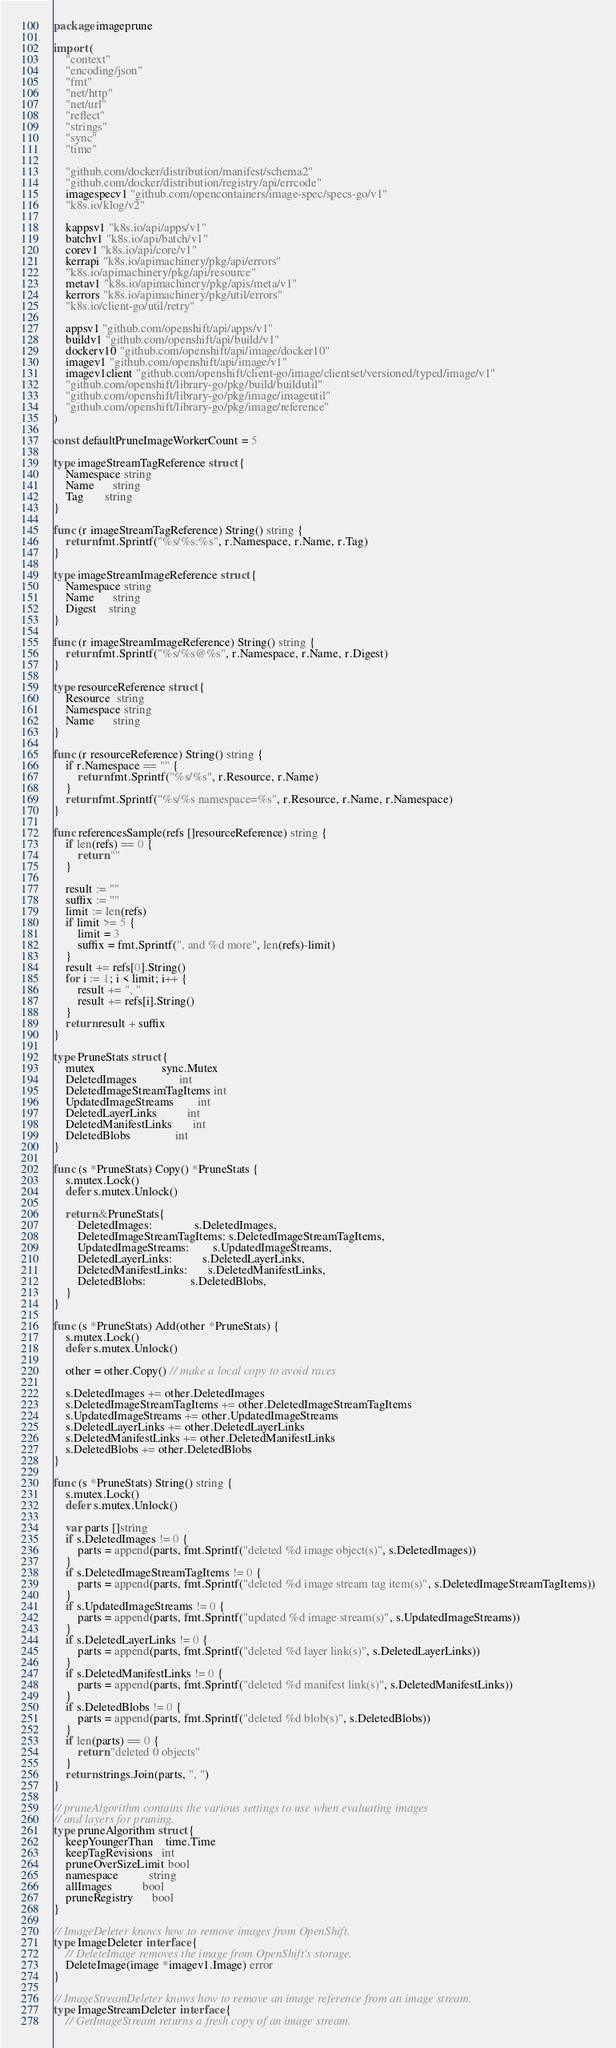<code> <loc_0><loc_0><loc_500><loc_500><_Go_>package imageprune

import (
	"context"
	"encoding/json"
	"fmt"
	"net/http"
	"net/url"
	"reflect"
	"strings"
	"sync"
	"time"

	"github.com/docker/distribution/manifest/schema2"
	"github.com/docker/distribution/registry/api/errcode"
	imagespecv1 "github.com/opencontainers/image-spec/specs-go/v1"
	"k8s.io/klog/v2"

	kappsv1 "k8s.io/api/apps/v1"
	batchv1 "k8s.io/api/batch/v1"
	corev1 "k8s.io/api/core/v1"
	kerrapi "k8s.io/apimachinery/pkg/api/errors"
	"k8s.io/apimachinery/pkg/api/resource"
	metav1 "k8s.io/apimachinery/pkg/apis/meta/v1"
	kerrors "k8s.io/apimachinery/pkg/util/errors"
	"k8s.io/client-go/util/retry"

	appsv1 "github.com/openshift/api/apps/v1"
	buildv1 "github.com/openshift/api/build/v1"
	dockerv10 "github.com/openshift/api/image/docker10"
	imagev1 "github.com/openshift/api/image/v1"
	imagev1client "github.com/openshift/client-go/image/clientset/versioned/typed/image/v1"
	"github.com/openshift/library-go/pkg/build/buildutil"
	"github.com/openshift/library-go/pkg/image/imageutil"
	"github.com/openshift/library-go/pkg/image/reference"
)

const defaultPruneImageWorkerCount = 5

type imageStreamTagReference struct {
	Namespace string
	Name      string
	Tag       string
}

func (r imageStreamTagReference) String() string {
	return fmt.Sprintf("%s/%s:%s", r.Namespace, r.Name, r.Tag)
}

type imageStreamImageReference struct {
	Namespace string
	Name      string
	Digest    string
}

func (r imageStreamImageReference) String() string {
	return fmt.Sprintf("%s/%s@%s", r.Namespace, r.Name, r.Digest)
}

type resourceReference struct {
	Resource  string
	Namespace string
	Name      string
}

func (r resourceReference) String() string {
	if r.Namespace == "" {
		return fmt.Sprintf("%s/%s", r.Resource, r.Name)
	}
	return fmt.Sprintf("%s/%s namespace=%s", r.Resource, r.Name, r.Namespace)
}

func referencesSample(refs []resourceReference) string {
	if len(refs) == 0 {
		return ""
	}

	result := ""
	suffix := ""
	limit := len(refs)
	if limit >= 5 {
		limit = 3
		suffix = fmt.Sprintf(", and %d more", len(refs)-limit)
	}
	result += refs[0].String()
	for i := 1; i < limit; i++ {
		result += ", "
		result += refs[i].String()
	}
	return result + suffix
}

type PruneStats struct {
	mutex                      sync.Mutex
	DeletedImages              int
	DeletedImageStreamTagItems int
	UpdatedImageStreams        int
	DeletedLayerLinks          int
	DeletedManifestLinks       int
	DeletedBlobs               int
}

func (s *PruneStats) Copy() *PruneStats {
	s.mutex.Lock()
	defer s.mutex.Unlock()

	return &PruneStats{
		DeletedImages:              s.DeletedImages,
		DeletedImageStreamTagItems: s.DeletedImageStreamTagItems,
		UpdatedImageStreams:        s.UpdatedImageStreams,
		DeletedLayerLinks:          s.DeletedLayerLinks,
		DeletedManifestLinks:       s.DeletedManifestLinks,
		DeletedBlobs:               s.DeletedBlobs,
	}
}

func (s *PruneStats) Add(other *PruneStats) {
	s.mutex.Lock()
	defer s.mutex.Unlock()

	other = other.Copy() // make a local copy to avoid races

	s.DeletedImages += other.DeletedImages
	s.DeletedImageStreamTagItems += other.DeletedImageStreamTagItems
	s.UpdatedImageStreams += other.UpdatedImageStreams
	s.DeletedLayerLinks += other.DeletedLayerLinks
	s.DeletedManifestLinks += other.DeletedManifestLinks
	s.DeletedBlobs += other.DeletedBlobs
}

func (s *PruneStats) String() string {
	s.mutex.Lock()
	defer s.mutex.Unlock()

	var parts []string
	if s.DeletedImages != 0 {
		parts = append(parts, fmt.Sprintf("deleted %d image object(s)", s.DeletedImages))
	}
	if s.DeletedImageStreamTagItems != 0 {
		parts = append(parts, fmt.Sprintf("deleted %d image stream tag item(s)", s.DeletedImageStreamTagItems))
	}
	if s.UpdatedImageStreams != 0 {
		parts = append(parts, fmt.Sprintf("updated %d image stream(s)", s.UpdatedImageStreams))
	}
	if s.DeletedLayerLinks != 0 {
		parts = append(parts, fmt.Sprintf("deleted %d layer link(s)", s.DeletedLayerLinks))
	}
	if s.DeletedManifestLinks != 0 {
		parts = append(parts, fmt.Sprintf("deleted %d manifest link(s)", s.DeletedManifestLinks))
	}
	if s.DeletedBlobs != 0 {
		parts = append(parts, fmt.Sprintf("deleted %d blob(s)", s.DeletedBlobs))
	}
	if len(parts) == 0 {
		return "deleted 0 objects"
	}
	return strings.Join(parts, ", ")
}

// pruneAlgorithm contains the various settings to use when evaluating images
// and layers for pruning.
type pruneAlgorithm struct {
	keepYoungerThan    time.Time
	keepTagRevisions   int
	pruneOverSizeLimit bool
	namespace          string
	allImages          bool
	pruneRegistry      bool
}

// ImageDeleter knows how to remove images from OpenShift.
type ImageDeleter interface {
	// DeleteImage removes the image from OpenShift's storage.
	DeleteImage(image *imagev1.Image) error
}

// ImageStreamDeleter knows how to remove an image reference from an image stream.
type ImageStreamDeleter interface {
	// GetImageStream returns a fresh copy of an image stream.</code> 